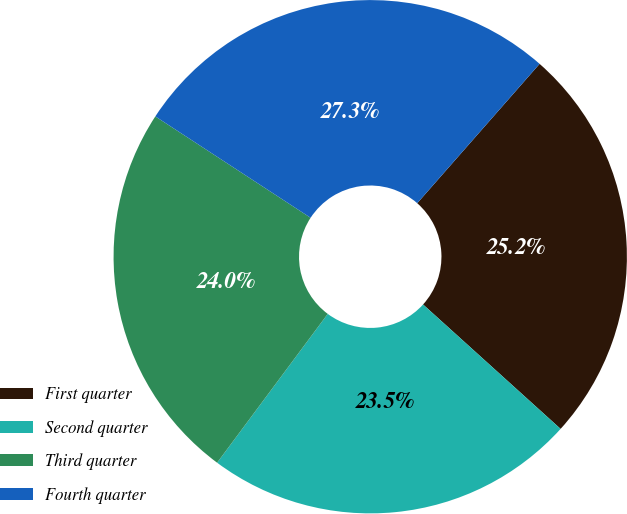Convert chart to OTSL. <chart><loc_0><loc_0><loc_500><loc_500><pie_chart><fcel>First quarter<fcel>Second quarter<fcel>Third quarter<fcel>Fourth quarter<nl><fcel>25.23%<fcel>23.47%<fcel>24.03%<fcel>27.26%<nl></chart> 